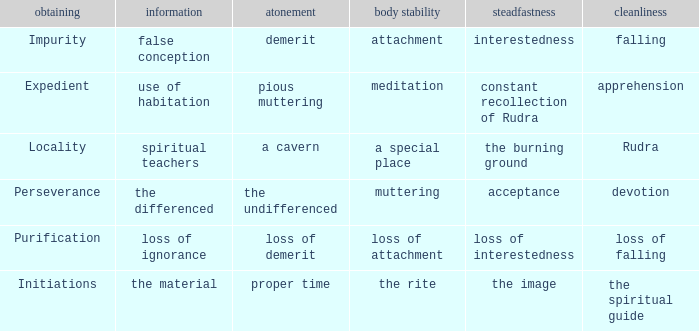Could you parse the entire table as a dict? {'header': ['obtaining', 'information', 'atonement', 'body stability', 'steadfastness', 'cleanliness'], 'rows': [['Impurity', 'false conception', 'demerit', 'attachment', 'interestedness', 'falling'], ['Expedient', 'use of habitation', 'pious muttering', 'meditation', 'constant recollection of Rudra', 'apprehension'], ['Locality', 'spiritual teachers', 'a cavern', 'a special place', 'the burning ground', 'Rudra'], ['Perseverance', 'the differenced', 'the undifferenced', 'muttering', 'acceptance', 'devotion'], ['Purification', 'loss of ignorance', 'loss of demerit', 'loss of attachment', 'loss of interestedness', 'loss of falling'], ['Initiations', 'the material', 'proper time', 'the rite', 'the image', 'the spiritual guide']]}  what's the permanence of the body where purity is apprehension Meditation. 